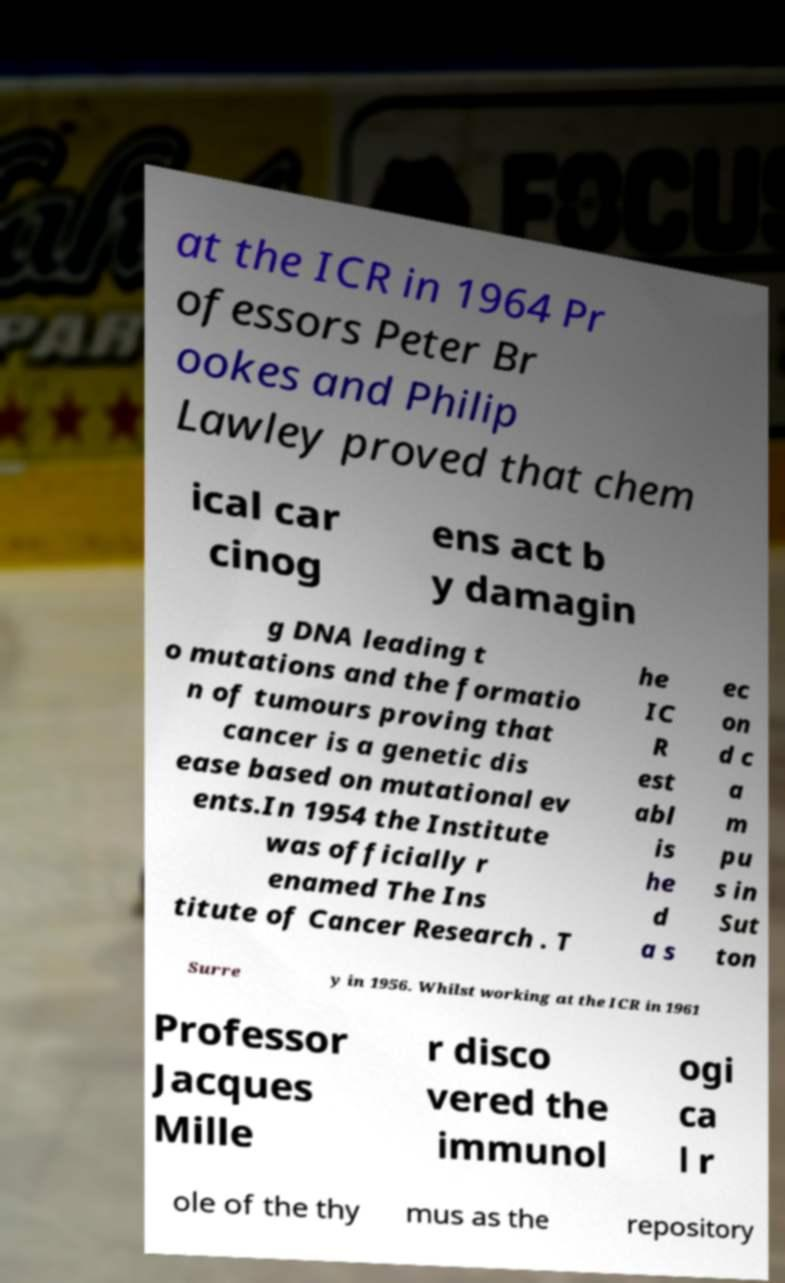Please read and relay the text visible in this image. What does it say? at the ICR in 1964 Pr ofessors Peter Br ookes and Philip Lawley proved that chem ical car cinog ens act b y damagin g DNA leading t o mutations and the formatio n of tumours proving that cancer is a genetic dis ease based on mutational ev ents.In 1954 the Institute was officially r enamed The Ins titute of Cancer Research . T he IC R est abl is he d a s ec on d c a m pu s in Sut ton Surre y in 1956. Whilst working at the ICR in 1961 Professor Jacques Mille r disco vered the immunol ogi ca l r ole of the thy mus as the repository 